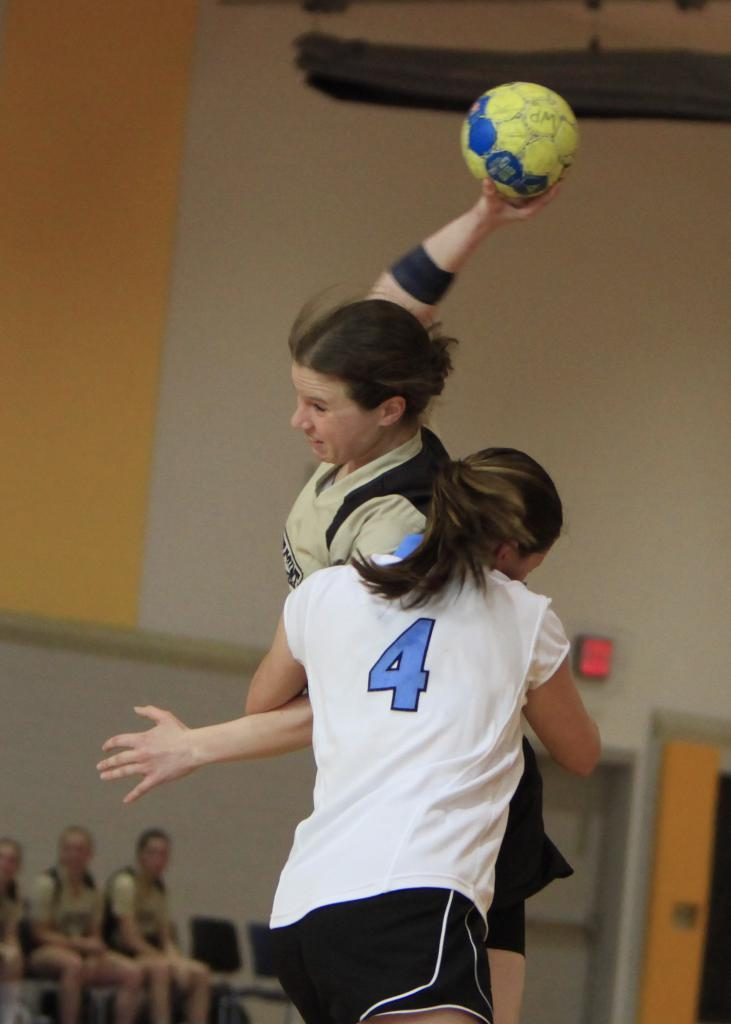<image>
Create a compact narrative representing the image presented. the number 4 on the shirt of a girl playing a sport 